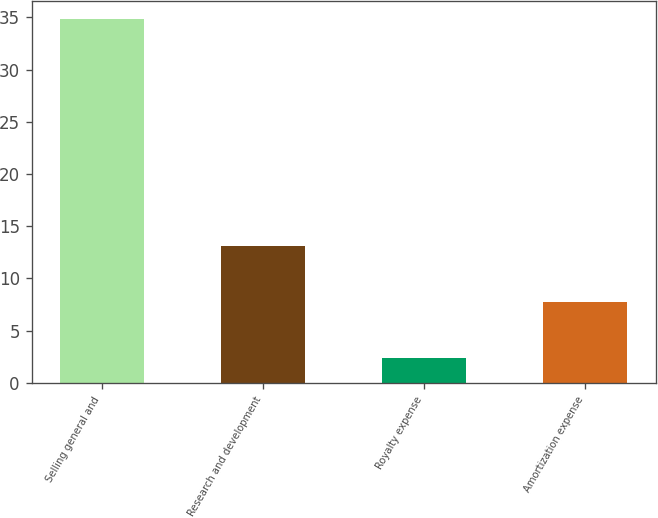Convert chart to OTSL. <chart><loc_0><loc_0><loc_500><loc_500><bar_chart><fcel>Selling general and<fcel>Research and development<fcel>Royalty expense<fcel>Amortization expense<nl><fcel>34.8<fcel>13.1<fcel>2.4<fcel>7.7<nl></chart> 